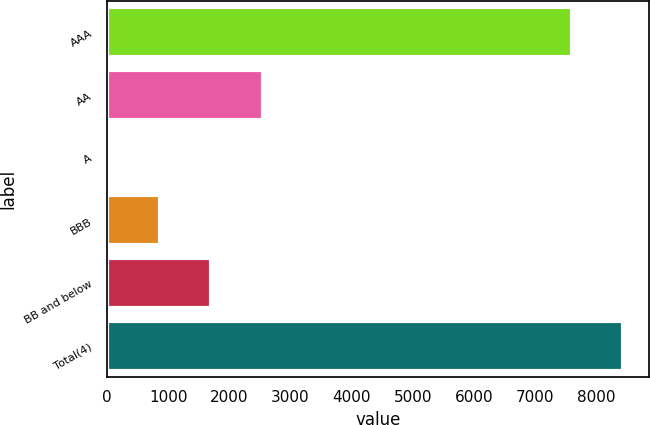<chart> <loc_0><loc_0><loc_500><loc_500><bar_chart><fcel>AAA<fcel>AA<fcel>A<fcel>BBB<fcel>BB and below<fcel>Total(4)<nl><fcel>7613<fcel>2544.7<fcel>40<fcel>874.9<fcel>1709.8<fcel>8447.9<nl></chart> 